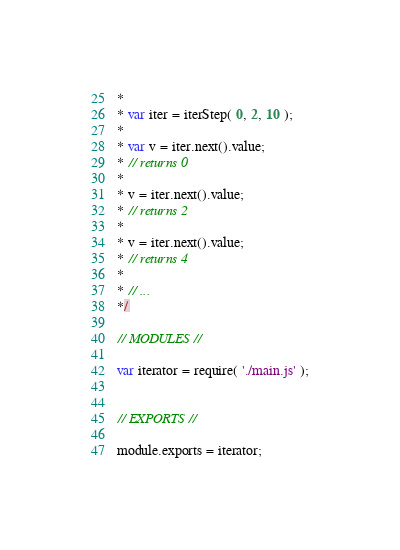<code> <loc_0><loc_0><loc_500><loc_500><_JavaScript_>*
* var iter = iterStep( 0, 2, 10 );
*
* var v = iter.next().value;
* // returns 0
*
* v = iter.next().value;
* // returns 2
*
* v = iter.next().value;
* // returns 4
*
* // ...
*/

// MODULES //

var iterator = require( './main.js' );


// EXPORTS //

module.exports = iterator;
</code> 